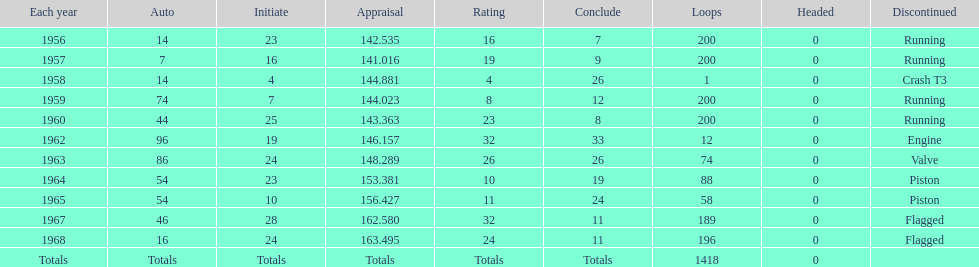How many times was bob veith ranked higher than 10 at an indy 500? 2. 